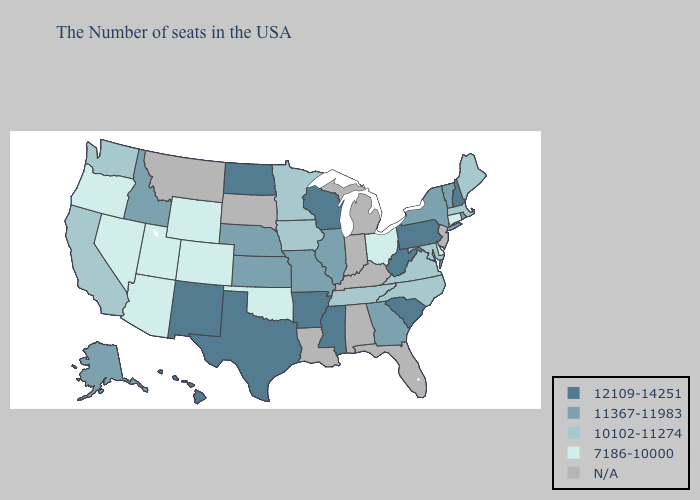Does Nevada have the highest value in the West?
Give a very brief answer. No. Does the map have missing data?
Give a very brief answer. Yes. What is the lowest value in states that border Nebraska?
Short answer required. 7186-10000. Which states have the lowest value in the USA?
Write a very short answer. Connecticut, Delaware, Ohio, Oklahoma, Wyoming, Colorado, Utah, Arizona, Nevada, Oregon. Name the states that have a value in the range 11367-11983?
Concise answer only. Rhode Island, Vermont, New York, Georgia, Illinois, Missouri, Kansas, Nebraska, Idaho, Alaska. What is the highest value in the South ?
Be succinct. 12109-14251. Does Ohio have the lowest value in the MidWest?
Answer briefly. Yes. What is the value of Massachusetts?
Be succinct. 10102-11274. What is the highest value in the Northeast ?
Short answer required. 12109-14251. Does North Dakota have the highest value in the USA?
Short answer required. Yes. Name the states that have a value in the range 12109-14251?
Quick response, please. New Hampshire, Pennsylvania, South Carolina, West Virginia, Wisconsin, Mississippi, Arkansas, Texas, North Dakota, New Mexico, Hawaii. What is the highest value in the West ?
Be succinct. 12109-14251. Name the states that have a value in the range 12109-14251?
Be succinct. New Hampshire, Pennsylvania, South Carolina, West Virginia, Wisconsin, Mississippi, Arkansas, Texas, North Dakota, New Mexico, Hawaii. What is the value of Rhode Island?
Give a very brief answer. 11367-11983. 